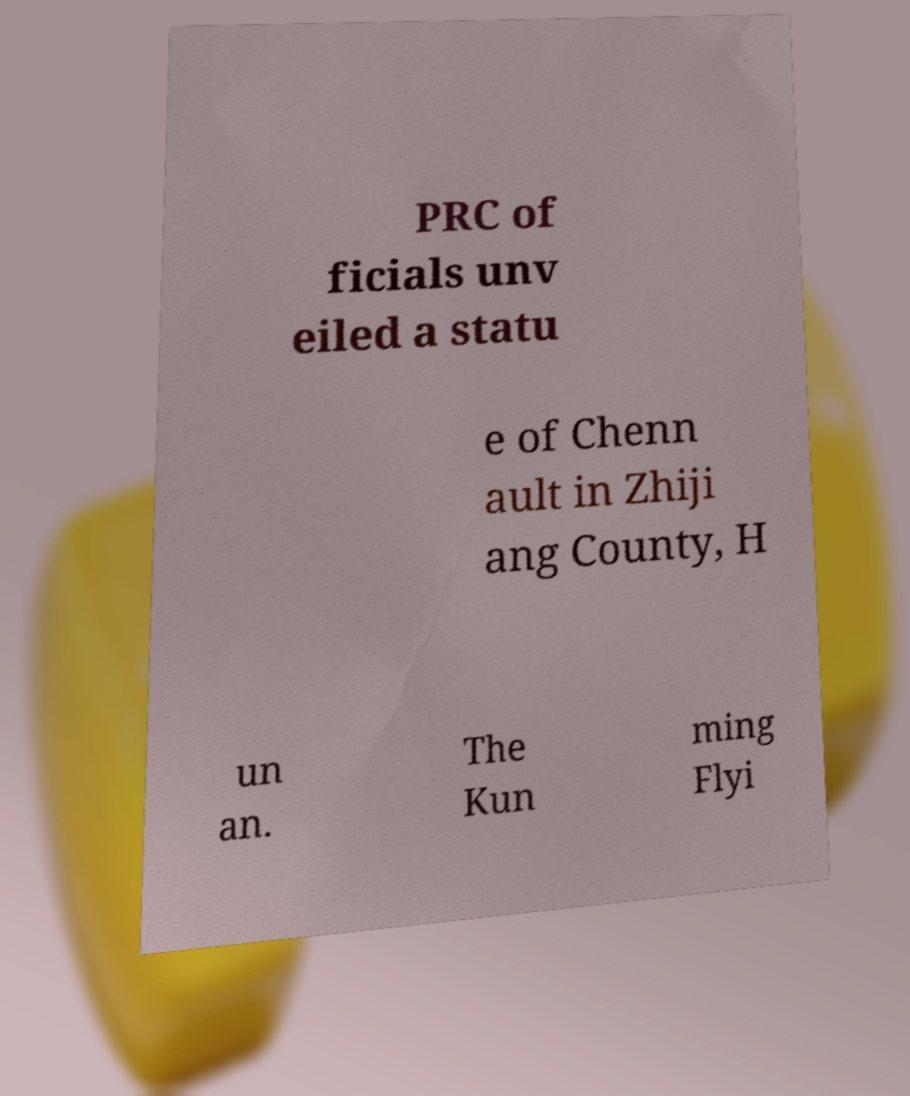There's text embedded in this image that I need extracted. Can you transcribe it verbatim? PRC of ficials unv eiled a statu e of Chenn ault in Zhiji ang County, H un an. The Kun ming Flyi 